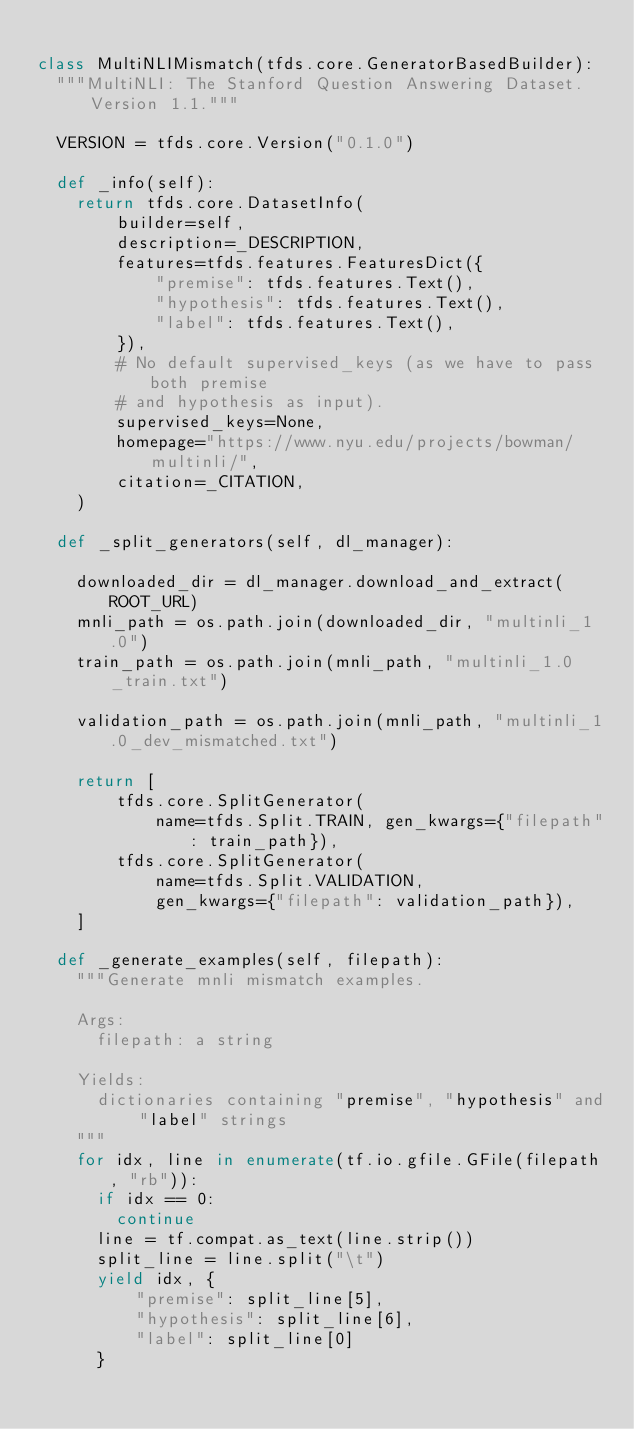<code> <loc_0><loc_0><loc_500><loc_500><_Python_>
class MultiNLIMismatch(tfds.core.GeneratorBasedBuilder):
  """MultiNLI: The Stanford Question Answering Dataset. Version 1.1."""

  VERSION = tfds.core.Version("0.1.0")

  def _info(self):
    return tfds.core.DatasetInfo(
        builder=self,
        description=_DESCRIPTION,
        features=tfds.features.FeaturesDict({
            "premise": tfds.features.Text(),
            "hypothesis": tfds.features.Text(),
            "label": tfds.features.Text(),
        }),
        # No default supervised_keys (as we have to pass both premise
        # and hypothesis as input).
        supervised_keys=None,
        homepage="https://www.nyu.edu/projects/bowman/multinli/",
        citation=_CITATION,
    )

  def _split_generators(self, dl_manager):

    downloaded_dir = dl_manager.download_and_extract(ROOT_URL)
    mnli_path = os.path.join(downloaded_dir, "multinli_1.0")
    train_path = os.path.join(mnli_path, "multinli_1.0_train.txt")

    validation_path = os.path.join(mnli_path, "multinli_1.0_dev_mismatched.txt")

    return [
        tfds.core.SplitGenerator(
            name=tfds.Split.TRAIN, gen_kwargs={"filepath": train_path}),
        tfds.core.SplitGenerator(
            name=tfds.Split.VALIDATION,
            gen_kwargs={"filepath": validation_path}),
    ]

  def _generate_examples(self, filepath):
    """Generate mnli mismatch examples.

    Args:
      filepath: a string

    Yields:
      dictionaries containing "premise", "hypothesis" and "label" strings
    """
    for idx, line in enumerate(tf.io.gfile.GFile(filepath, "rb")):
      if idx == 0:
        continue
      line = tf.compat.as_text(line.strip())
      split_line = line.split("\t")
      yield idx, {
          "premise": split_line[5],
          "hypothesis": split_line[6],
          "label": split_line[0]
      }
</code> 